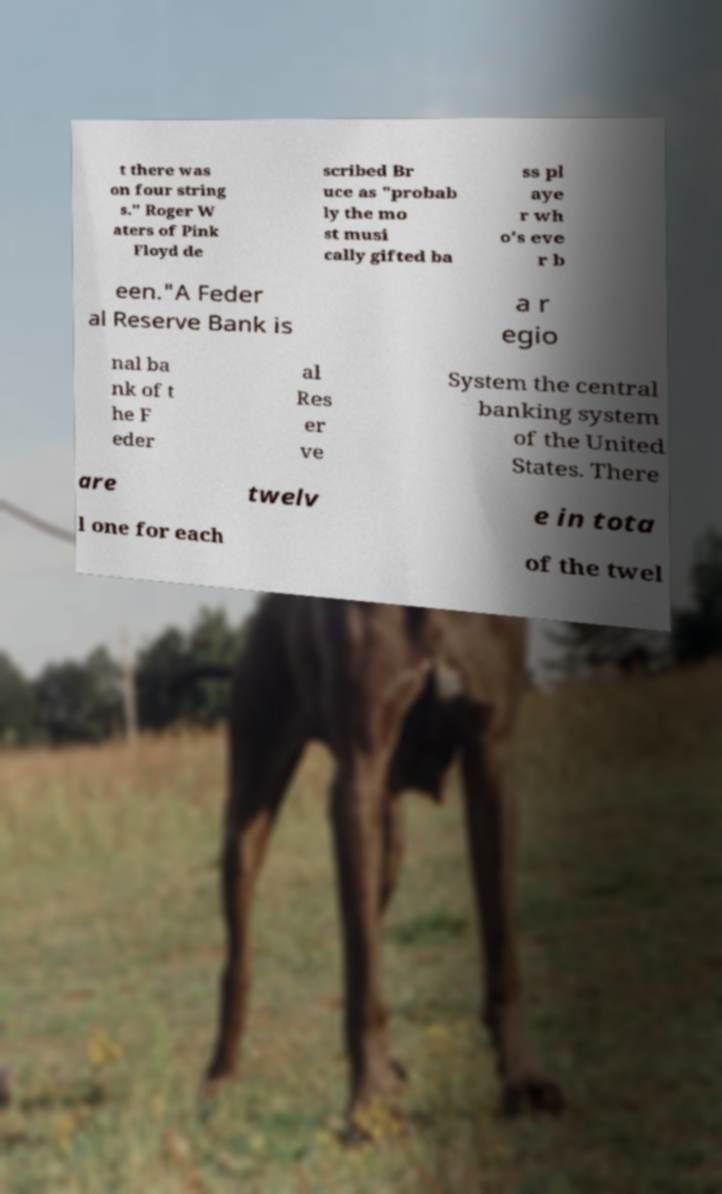For documentation purposes, I need the text within this image transcribed. Could you provide that? t there was on four string s." Roger W aters of Pink Floyd de scribed Br uce as "probab ly the mo st musi cally gifted ba ss pl aye r wh o's eve r b een."A Feder al Reserve Bank is a r egio nal ba nk of t he F eder al Res er ve System the central banking system of the United States. There are twelv e in tota l one for each of the twel 